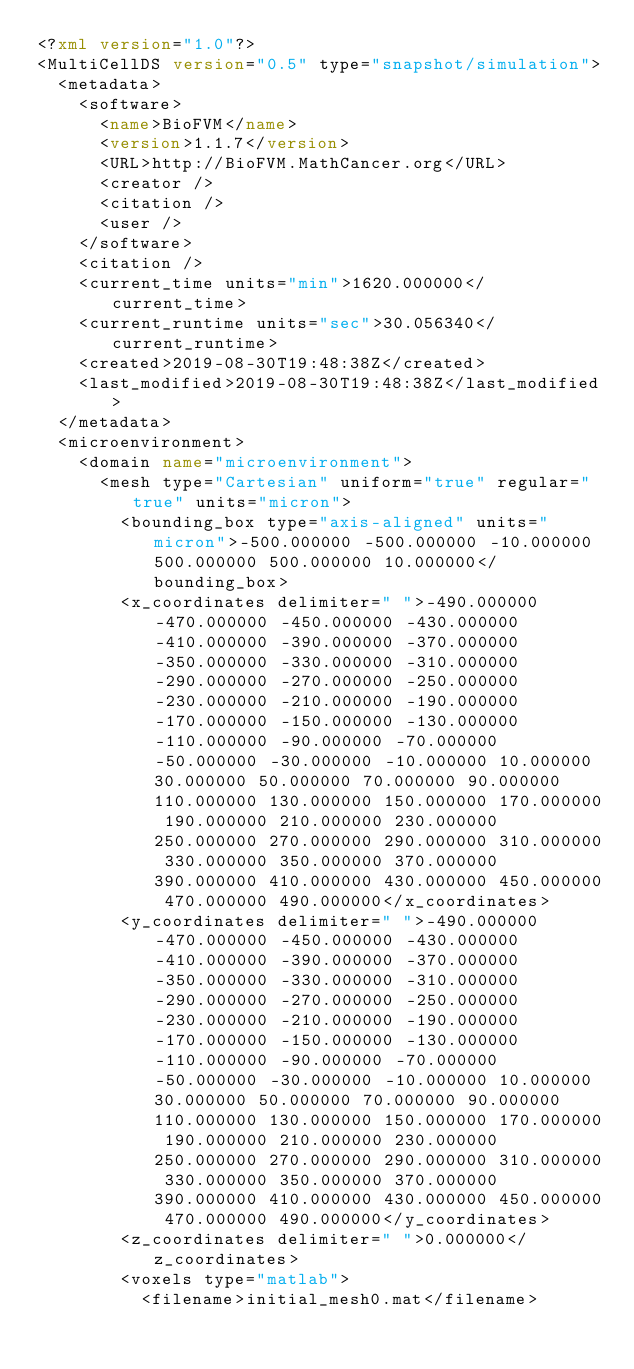<code> <loc_0><loc_0><loc_500><loc_500><_XML_><?xml version="1.0"?>
<MultiCellDS version="0.5" type="snapshot/simulation">
	<metadata>
		<software>
			<name>BioFVM</name>
			<version>1.1.7</version>
			<URL>http://BioFVM.MathCancer.org</URL>
			<creator />
			<citation />
			<user />
		</software>
		<citation />
		<current_time units="min">1620.000000</current_time>
		<current_runtime units="sec">30.056340</current_runtime>
		<created>2019-08-30T19:48:38Z</created>
		<last_modified>2019-08-30T19:48:38Z</last_modified>
	</metadata>
	<microenvironment>
		<domain name="microenvironment">
			<mesh type="Cartesian" uniform="true" regular="true" units="micron">
				<bounding_box type="axis-aligned" units="micron">-500.000000 -500.000000 -10.000000 500.000000 500.000000 10.000000</bounding_box>
				<x_coordinates delimiter=" ">-490.000000 -470.000000 -450.000000 -430.000000 -410.000000 -390.000000 -370.000000 -350.000000 -330.000000 -310.000000 -290.000000 -270.000000 -250.000000 -230.000000 -210.000000 -190.000000 -170.000000 -150.000000 -130.000000 -110.000000 -90.000000 -70.000000 -50.000000 -30.000000 -10.000000 10.000000 30.000000 50.000000 70.000000 90.000000 110.000000 130.000000 150.000000 170.000000 190.000000 210.000000 230.000000 250.000000 270.000000 290.000000 310.000000 330.000000 350.000000 370.000000 390.000000 410.000000 430.000000 450.000000 470.000000 490.000000</x_coordinates>
				<y_coordinates delimiter=" ">-490.000000 -470.000000 -450.000000 -430.000000 -410.000000 -390.000000 -370.000000 -350.000000 -330.000000 -310.000000 -290.000000 -270.000000 -250.000000 -230.000000 -210.000000 -190.000000 -170.000000 -150.000000 -130.000000 -110.000000 -90.000000 -70.000000 -50.000000 -30.000000 -10.000000 10.000000 30.000000 50.000000 70.000000 90.000000 110.000000 130.000000 150.000000 170.000000 190.000000 210.000000 230.000000 250.000000 270.000000 290.000000 310.000000 330.000000 350.000000 370.000000 390.000000 410.000000 430.000000 450.000000 470.000000 490.000000</y_coordinates>
				<z_coordinates delimiter=" ">0.000000</z_coordinates>
				<voxels type="matlab">
					<filename>initial_mesh0.mat</filename></code> 